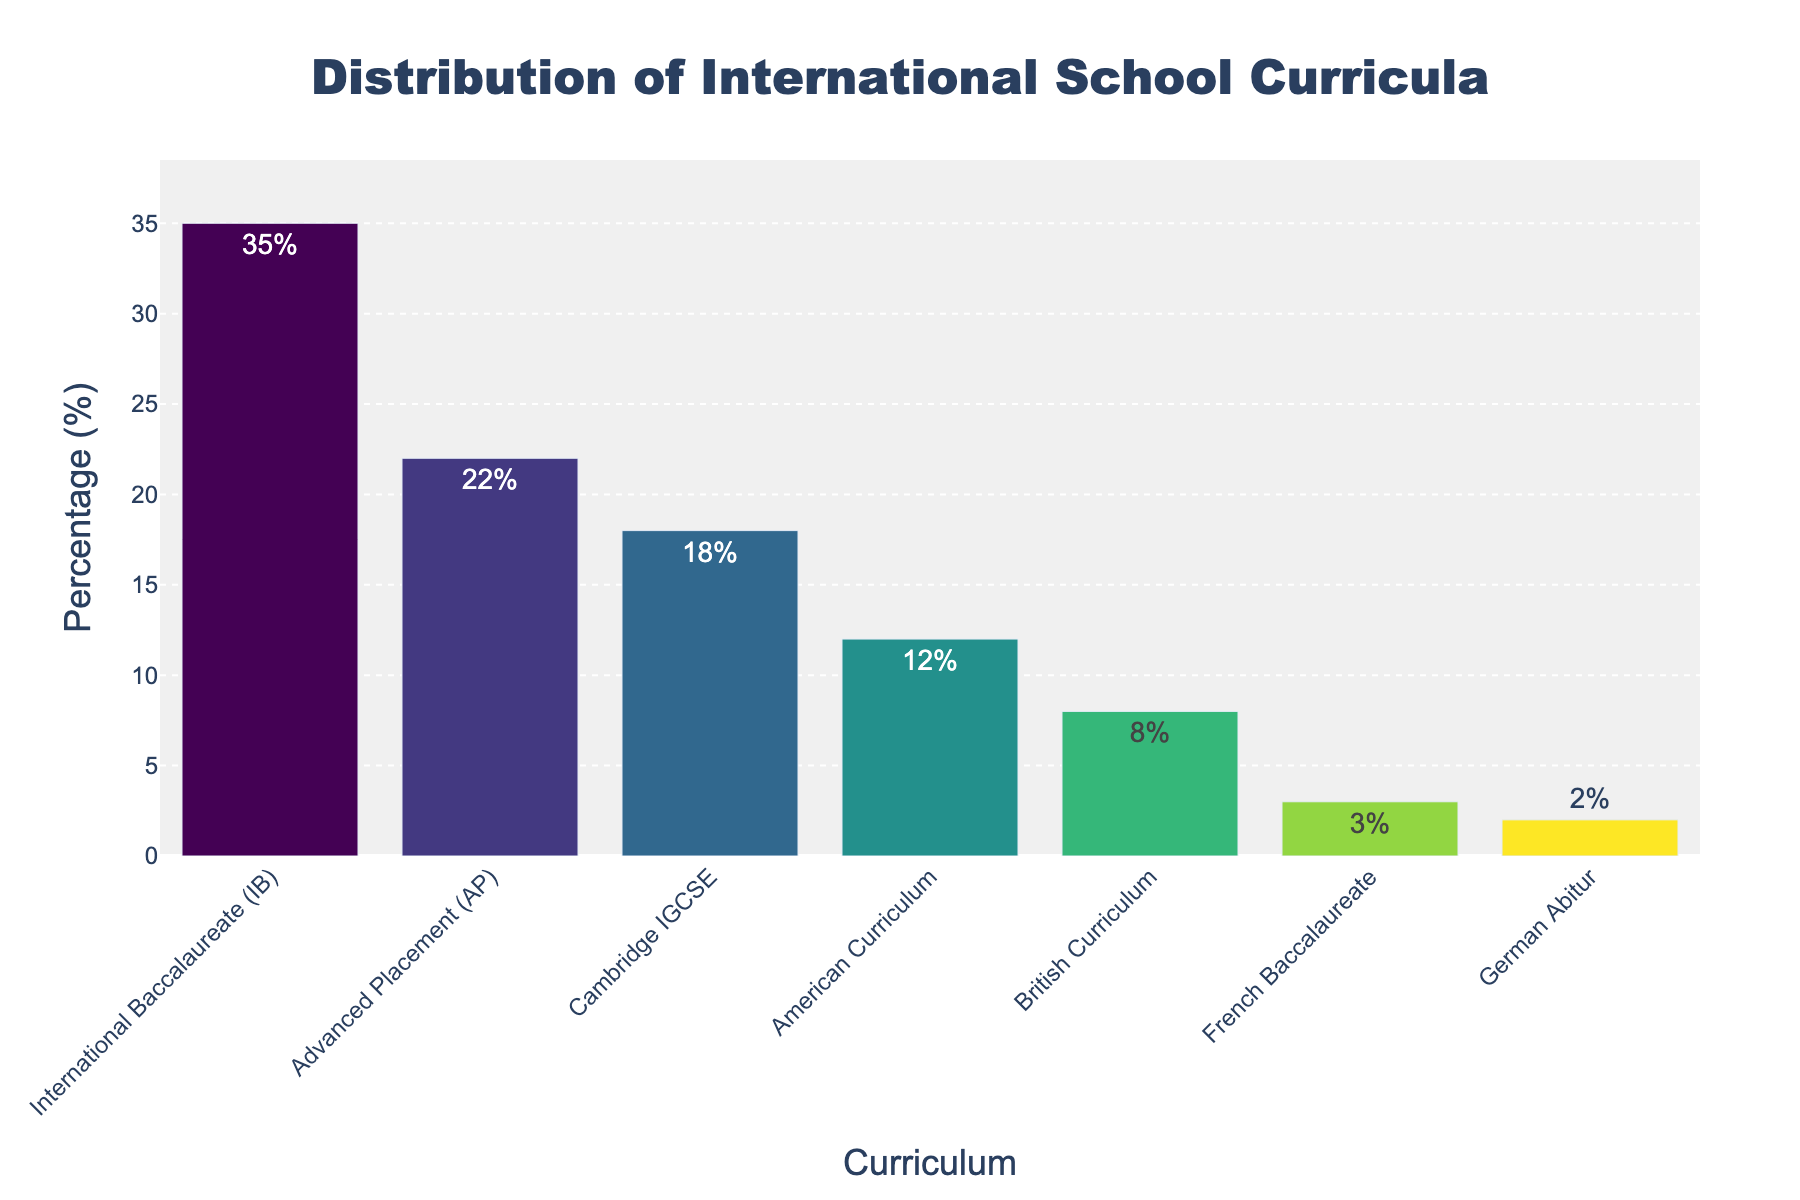what's the total percentage of schools offering the top three curricula? First, identify the percentages of the top three curricula: IB (35%), AP (22%), and Cambridge IGCSE (18%). Add these percentages together: 35 + 22 + 18 = 75.
Answer: 75 which curriculum has the smallest percentage of offerings? Look at the percentages and identify the smallest value: German Abitur has 2%.
Answer: German Abitur how many curricula have a percentage greater than 10? Identify the curricula with percentages greater than 10: IB (35%), AP (22%), Cambridge IGCSE (18%), and American Curriculum (12%). Count these curricula: 4.
Answer: 4 what is the percentage difference between the International Baccalaureate and the British Curriculum? Identify the percentages for International Baccalaureate (35%) and British Curriculum (8%). Subtract the smaller percentage from the larger one: 35 - 8 = 27.
Answer: 27 which curriculum offerings are less than half of those of the International Baccalaureate? Identify half of International Baccalaureate's percentage: 35/2 = 17.5. Find curricula with percentages less than 17.5: American Curriculum (12%), British Curriculum (8%), French Baccalaureate (3%), and German Abitur (2%).
Answer: American Curriculum, British Curriculum, French Baccalaureate, German Abitur are there more schools offering the French Baccalaureate or the German Abitur? Compare the percentages of the French Baccalaureate (3%) and German Abitur (2%). 3% is greater than 2%.
Answer: French Baccalaureate what is the height of the tallest bar? The height of the tallest bar represents the highest percentage, which is 35% for International Baccalaureate.
Answer: 35 which curricula have similar heights in the plot? Identify the curricula with similar percentages: Cambridge IGCSE (18%) and American Curriculum (12%) have a difference of 6%, while British Curriculum (8%), French Baccalaureate (3%), and German Abitur (2%) have minor differences.
Answer: Cambridge IGCSE and American Curriculum if we combine the American and British Curricula offerings, how does their total percentage compare to the International Baccalaureate? Combine the percentages for American Curriculum (12%) and British Curriculum (8%): 12 + 8 = 20. Compare to International Baccalaureate's percentage (35%): 20 < 35.
Answer: Less how much higher is the percentage of AP offerings compared to French Baccalaureate offerings? Calculate the difference between AP (22%) and French Baccalaureate (3%): 22 - 3 = 19.
Answer: 19 